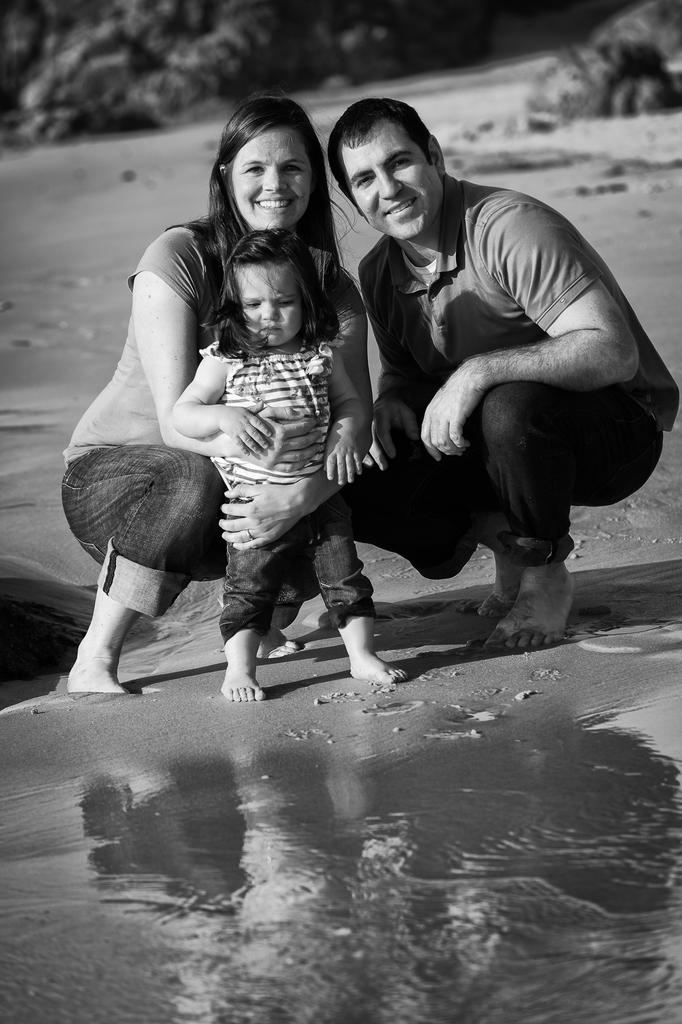Who are the people in the image? There is a couple in the image. Are there any children present in the image? Yes, there is a kid in the image. What type of vegetation can be seen in the image? There are plants in the image. What natural element is visible in the image? There is water visible in the image. What type of pet is being held by the committee in the image? There is no committee or pet present in the image. 